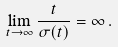<formula> <loc_0><loc_0><loc_500><loc_500>\lim _ { t \to \infty } \frac { t } { \sigma ( t ) } = \infty \, .</formula> 